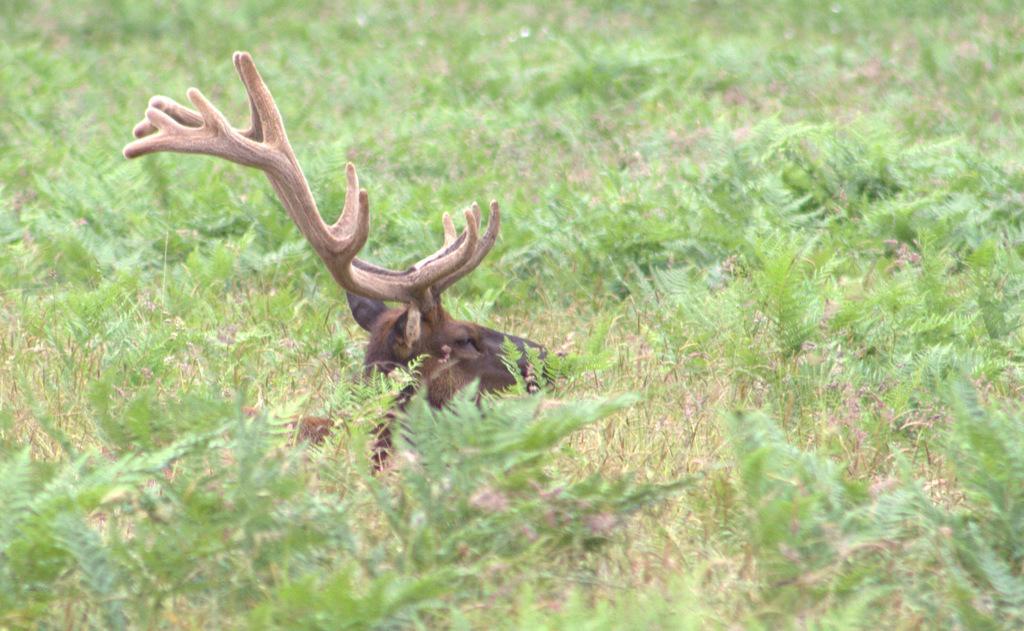Please provide a concise description of this image. In this image, we can see some plants. There is an animal in the middle of the image. 